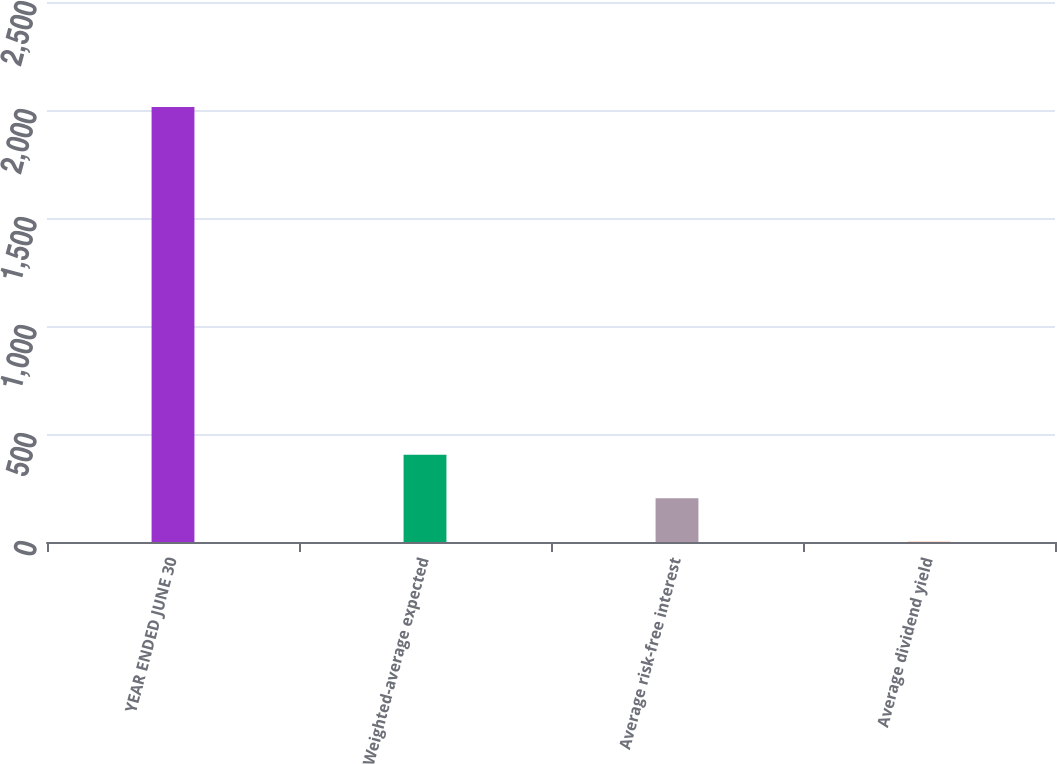Convert chart. <chart><loc_0><loc_0><loc_500><loc_500><bar_chart><fcel>YEAR ENDED JUNE 30<fcel>Weighted-average expected<fcel>Average risk-free interest<fcel>Average dividend yield<nl><fcel>2014<fcel>403.68<fcel>202.39<fcel>1.1<nl></chart> 